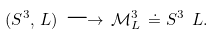Convert formula to latex. <formula><loc_0><loc_0><loc_500><loc_500>( S ^ { 3 } , \, L ) \, \longrightarrow \, \mathcal { M } ^ { 3 } _ { L } \, \doteq S ^ { 3 } \ L .</formula> 